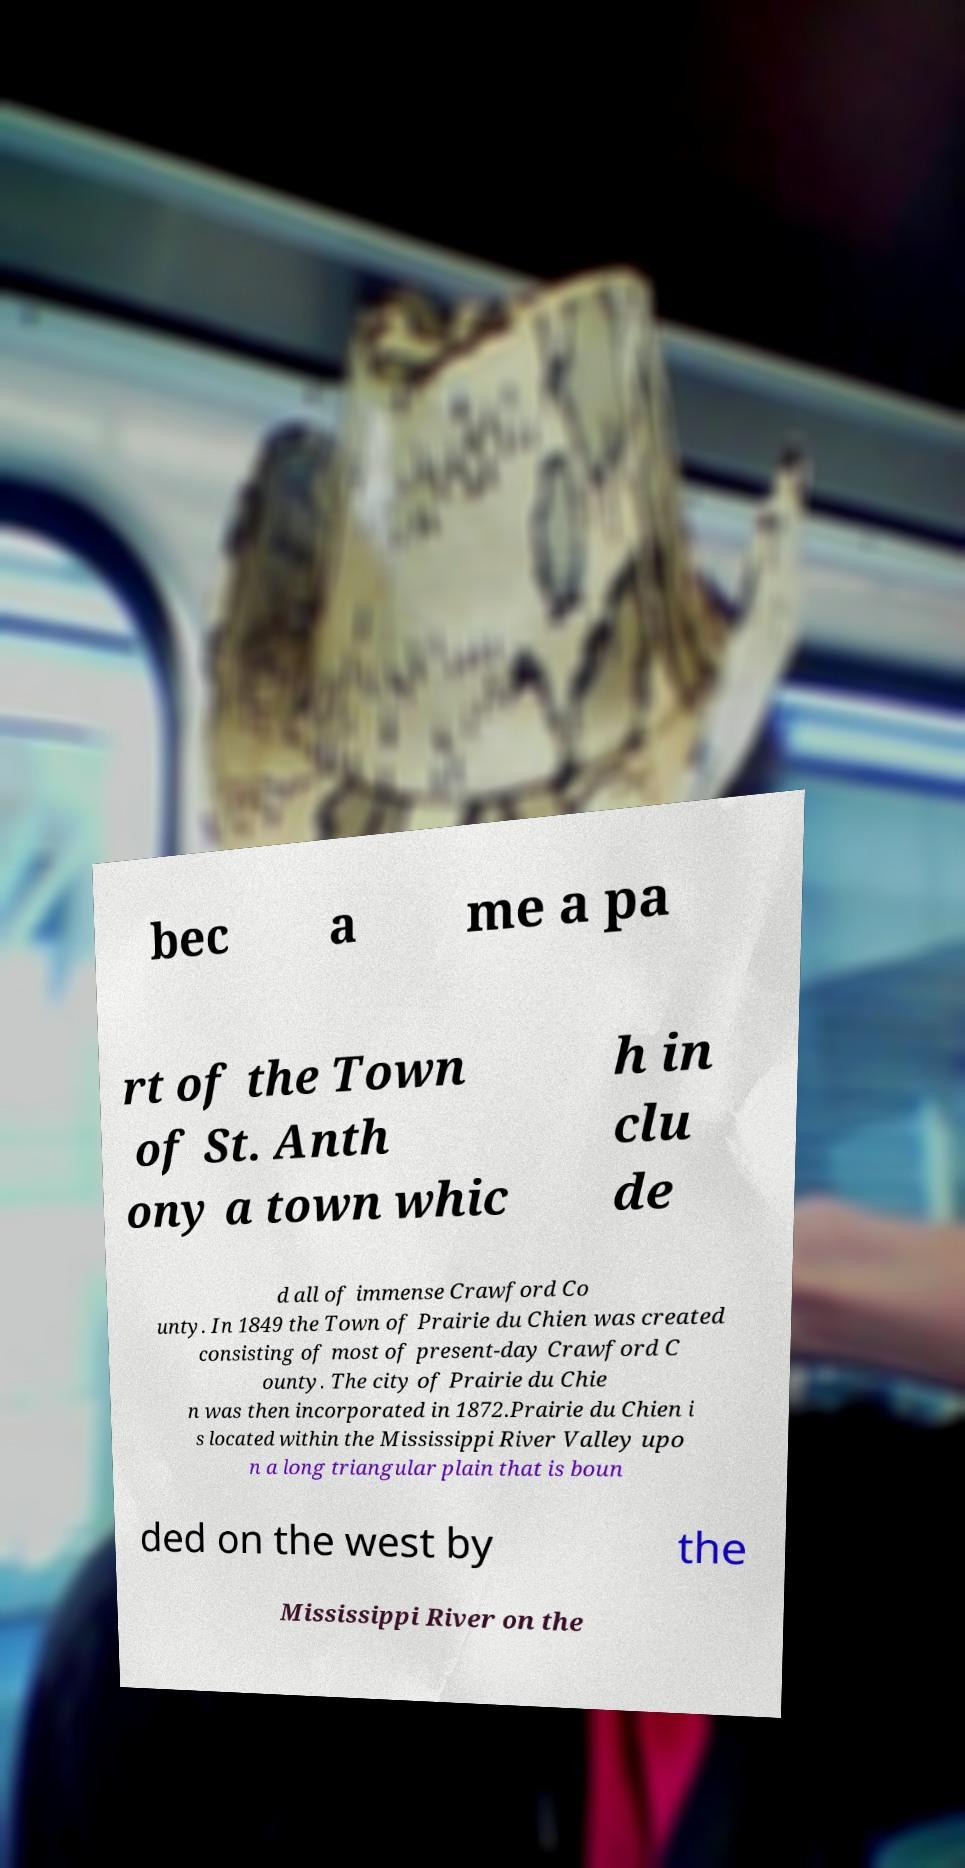There's text embedded in this image that I need extracted. Can you transcribe it verbatim? bec a me a pa rt of the Town of St. Anth ony a town whic h in clu de d all of immense Crawford Co unty. In 1849 the Town of Prairie du Chien was created consisting of most of present-day Crawford C ounty. The city of Prairie du Chie n was then incorporated in 1872.Prairie du Chien i s located within the Mississippi River Valley upo n a long triangular plain that is boun ded on the west by the Mississippi River on the 